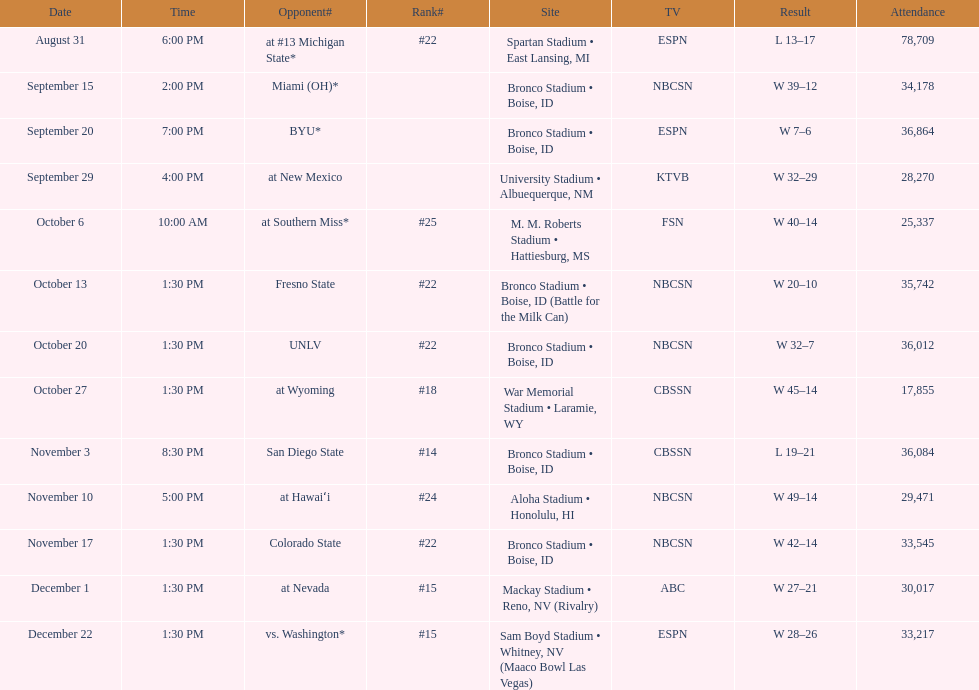Calculate the total sum of points achieved in the recent victories for boise state. 146. 